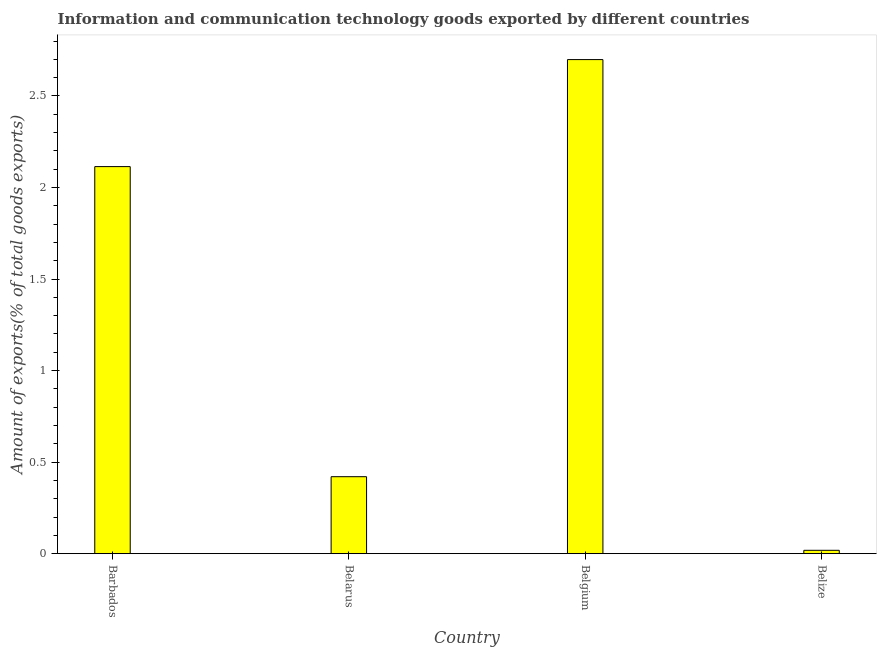What is the title of the graph?
Provide a short and direct response. Information and communication technology goods exported by different countries. What is the label or title of the X-axis?
Offer a very short reply. Country. What is the label or title of the Y-axis?
Your response must be concise. Amount of exports(% of total goods exports). What is the amount of ict goods exports in Belgium?
Make the answer very short. 2.7. Across all countries, what is the maximum amount of ict goods exports?
Ensure brevity in your answer.  2.7. Across all countries, what is the minimum amount of ict goods exports?
Keep it short and to the point. 0.02. In which country was the amount of ict goods exports maximum?
Provide a succinct answer. Belgium. In which country was the amount of ict goods exports minimum?
Your response must be concise. Belize. What is the sum of the amount of ict goods exports?
Offer a very short reply. 5.25. What is the difference between the amount of ict goods exports in Belarus and Belize?
Ensure brevity in your answer.  0.4. What is the average amount of ict goods exports per country?
Offer a terse response. 1.31. What is the median amount of ict goods exports?
Your answer should be very brief. 1.27. What is the ratio of the amount of ict goods exports in Belgium to that in Belize?
Your answer should be very brief. 147.74. Is the amount of ict goods exports in Belgium less than that in Belize?
Ensure brevity in your answer.  No. What is the difference between the highest and the second highest amount of ict goods exports?
Offer a terse response. 0.58. What is the difference between the highest and the lowest amount of ict goods exports?
Your answer should be compact. 2.68. How many bars are there?
Make the answer very short. 4. Are all the bars in the graph horizontal?
Provide a short and direct response. No. How many countries are there in the graph?
Provide a succinct answer. 4. Are the values on the major ticks of Y-axis written in scientific E-notation?
Provide a succinct answer. No. What is the Amount of exports(% of total goods exports) in Barbados?
Provide a short and direct response. 2.11. What is the Amount of exports(% of total goods exports) of Belarus?
Provide a succinct answer. 0.42. What is the Amount of exports(% of total goods exports) of Belgium?
Provide a short and direct response. 2.7. What is the Amount of exports(% of total goods exports) of Belize?
Your response must be concise. 0.02. What is the difference between the Amount of exports(% of total goods exports) in Barbados and Belarus?
Your answer should be very brief. 1.69. What is the difference between the Amount of exports(% of total goods exports) in Barbados and Belgium?
Offer a very short reply. -0.58. What is the difference between the Amount of exports(% of total goods exports) in Barbados and Belize?
Give a very brief answer. 2.1. What is the difference between the Amount of exports(% of total goods exports) in Belarus and Belgium?
Your answer should be compact. -2.28. What is the difference between the Amount of exports(% of total goods exports) in Belarus and Belize?
Ensure brevity in your answer.  0.4. What is the difference between the Amount of exports(% of total goods exports) in Belgium and Belize?
Provide a short and direct response. 2.68. What is the ratio of the Amount of exports(% of total goods exports) in Barbados to that in Belarus?
Provide a short and direct response. 5.03. What is the ratio of the Amount of exports(% of total goods exports) in Barbados to that in Belgium?
Provide a short and direct response. 0.78. What is the ratio of the Amount of exports(% of total goods exports) in Barbados to that in Belize?
Offer a terse response. 115.73. What is the ratio of the Amount of exports(% of total goods exports) in Belarus to that in Belgium?
Your response must be concise. 0.16. What is the ratio of the Amount of exports(% of total goods exports) in Belarus to that in Belize?
Keep it short and to the point. 23.01. What is the ratio of the Amount of exports(% of total goods exports) in Belgium to that in Belize?
Your answer should be very brief. 147.74. 